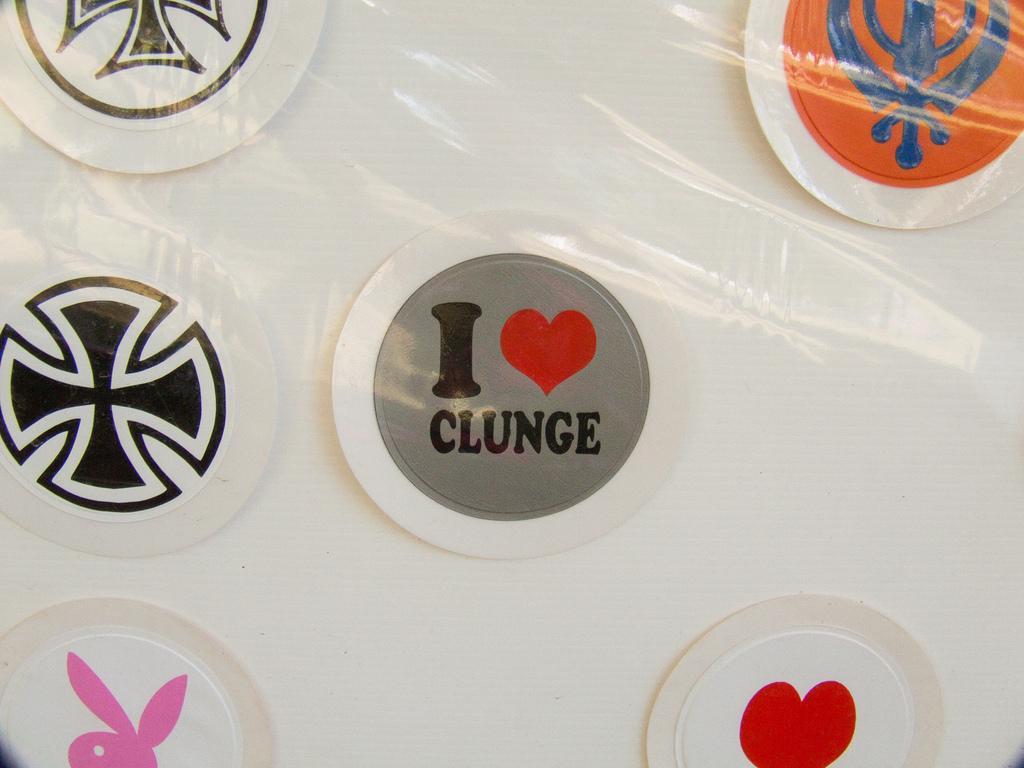Please provide a concise description of this image. In this image there are circular objects, there is text on the circular object, there are circular objects truncated towards the bottom of the image, there are circular objects truncated towards the top of the image, there are circular objects truncated towards the left of the image, there are circular objects truncated towards the right of the image, at the background of the image there is a white color truncated. 